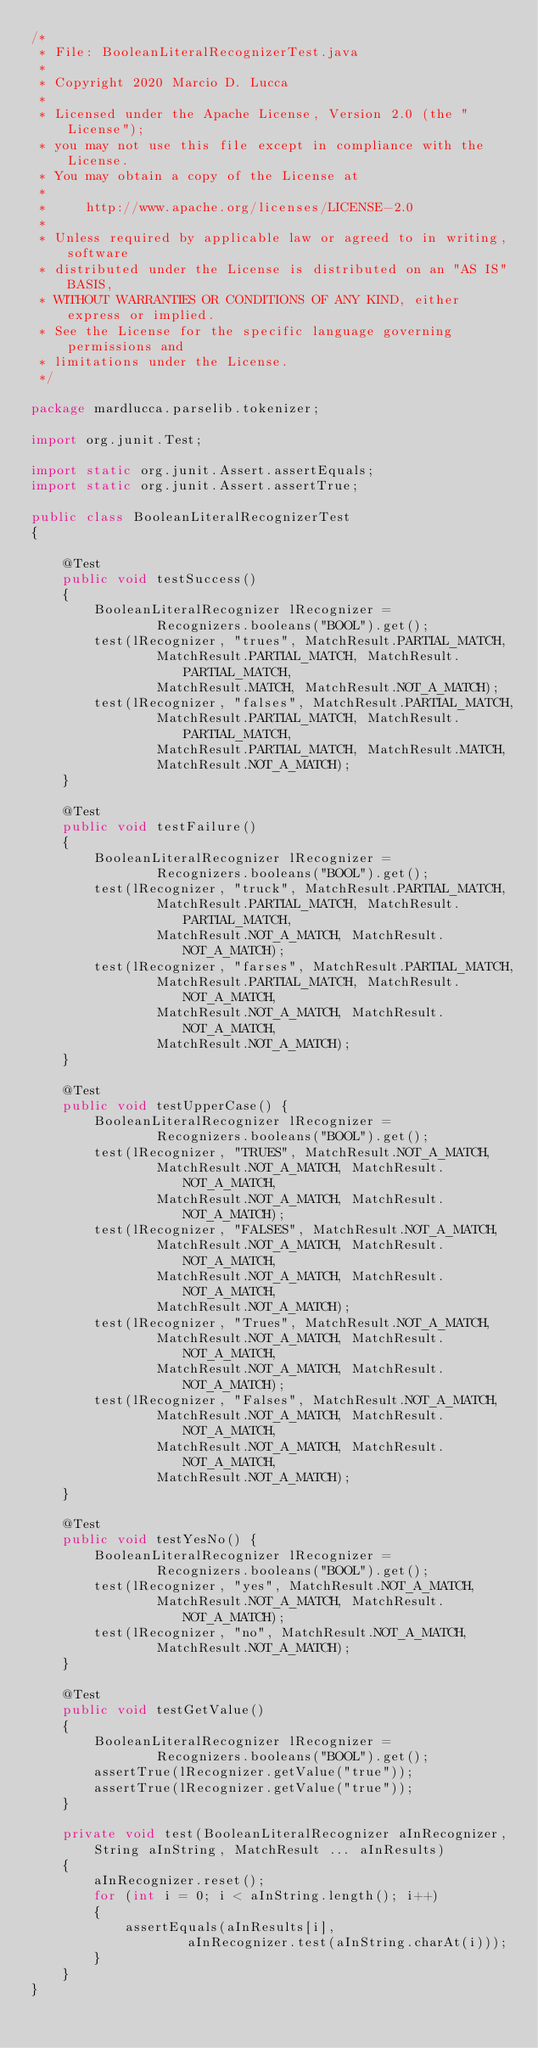Convert code to text. <code><loc_0><loc_0><loc_500><loc_500><_Java_>/*
 * File: BooleanLiteralRecognizerTest.java
 *
 * Copyright 2020 Marcio D. Lucca
 *
 * Licensed under the Apache License, Version 2.0 (the "License");
 * you may not use this file except in compliance with the License.
 * You may obtain a copy of the License at
 *
 *     http://www.apache.org/licenses/LICENSE-2.0
 *
 * Unless required by applicable law or agreed to in writing, software
 * distributed under the License is distributed on an "AS IS" BASIS,
 * WITHOUT WARRANTIES OR CONDITIONS OF ANY KIND, either express or implied.
 * See the License for the specific language governing permissions and
 * limitations under the License.
 */

package mardlucca.parselib.tokenizer;

import org.junit.Test;

import static org.junit.Assert.assertEquals;
import static org.junit.Assert.assertTrue;

public class BooleanLiteralRecognizerTest
{

    @Test
    public void testSuccess()
    {
        BooleanLiteralRecognizer lRecognizer =
                Recognizers.booleans("BOOL").get();
        test(lRecognizer, "trues", MatchResult.PARTIAL_MATCH,
                MatchResult.PARTIAL_MATCH, MatchResult.PARTIAL_MATCH,
                MatchResult.MATCH, MatchResult.NOT_A_MATCH);
        test(lRecognizer, "falses", MatchResult.PARTIAL_MATCH,
                MatchResult.PARTIAL_MATCH, MatchResult.PARTIAL_MATCH,
                MatchResult.PARTIAL_MATCH, MatchResult.MATCH,
                MatchResult.NOT_A_MATCH);
    }

    @Test
    public void testFailure()
    {
        BooleanLiteralRecognizer lRecognizer =
                Recognizers.booleans("BOOL").get();
        test(lRecognizer, "truck", MatchResult.PARTIAL_MATCH,
                MatchResult.PARTIAL_MATCH, MatchResult.PARTIAL_MATCH,
                MatchResult.NOT_A_MATCH, MatchResult.NOT_A_MATCH);
        test(lRecognizer, "farses", MatchResult.PARTIAL_MATCH,
                MatchResult.PARTIAL_MATCH, MatchResult.NOT_A_MATCH,
                MatchResult.NOT_A_MATCH, MatchResult.NOT_A_MATCH,
                MatchResult.NOT_A_MATCH);
    }

    @Test
    public void testUpperCase() {
        BooleanLiteralRecognizer lRecognizer =
                Recognizers.booleans("BOOL").get();
        test(lRecognizer, "TRUES", MatchResult.NOT_A_MATCH,
                MatchResult.NOT_A_MATCH, MatchResult.NOT_A_MATCH,
                MatchResult.NOT_A_MATCH, MatchResult.NOT_A_MATCH);
        test(lRecognizer, "FALSES", MatchResult.NOT_A_MATCH,
                MatchResult.NOT_A_MATCH, MatchResult.NOT_A_MATCH,
                MatchResult.NOT_A_MATCH, MatchResult.NOT_A_MATCH,
                MatchResult.NOT_A_MATCH);
        test(lRecognizer, "Trues", MatchResult.NOT_A_MATCH,
                MatchResult.NOT_A_MATCH, MatchResult.NOT_A_MATCH,
                MatchResult.NOT_A_MATCH, MatchResult.NOT_A_MATCH);
        test(lRecognizer, "Falses", MatchResult.NOT_A_MATCH,
                MatchResult.NOT_A_MATCH, MatchResult.NOT_A_MATCH,
                MatchResult.NOT_A_MATCH, MatchResult.NOT_A_MATCH,
                MatchResult.NOT_A_MATCH);
    }

    @Test
    public void testYesNo() {
        BooleanLiteralRecognizer lRecognizer =
                Recognizers.booleans("BOOL").get();
        test(lRecognizer, "yes", MatchResult.NOT_A_MATCH,
                MatchResult.NOT_A_MATCH, MatchResult.NOT_A_MATCH);
        test(lRecognizer, "no", MatchResult.NOT_A_MATCH,
                MatchResult.NOT_A_MATCH);
    }

    @Test
    public void testGetValue()
    {
        BooleanLiteralRecognizer lRecognizer =
                Recognizers.booleans("BOOL").get();
        assertTrue(lRecognizer.getValue("true"));
        assertTrue(lRecognizer.getValue("true"));
    }

    private void test(BooleanLiteralRecognizer aInRecognizer,
        String aInString, MatchResult ... aInResults)
    {
        aInRecognizer.reset();
        for (int i = 0; i < aInString.length(); i++)
        {
            assertEquals(aInResults[i],
                    aInRecognizer.test(aInString.charAt(i)));
        }
    }
}</code> 